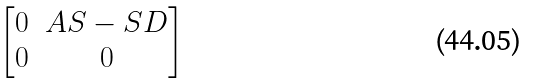Convert formula to latex. <formula><loc_0><loc_0><loc_500><loc_500>\begin{bmatrix} 0 & A S - S D \\ 0 & 0 \end{bmatrix}</formula> 